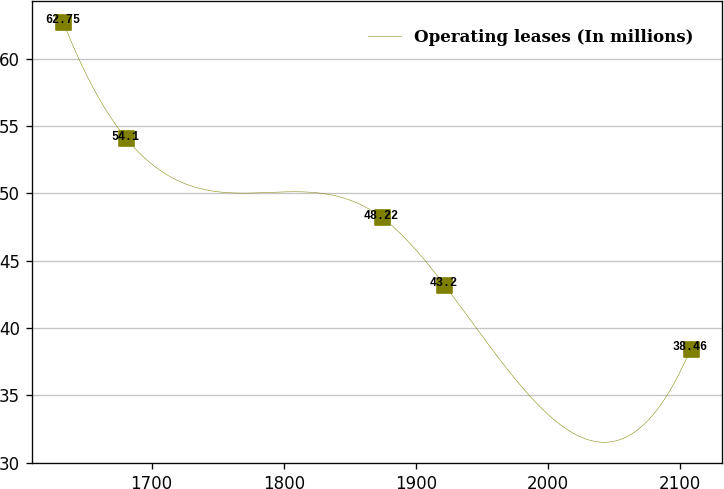Convert chart to OTSL. <chart><loc_0><loc_0><loc_500><loc_500><line_chart><ecel><fcel>Operating leases (In millions)<nl><fcel>1633.13<fcel>62.75<nl><fcel>1680.61<fcel>54.1<nl><fcel>1874.01<fcel>48.22<nl><fcel>1921.49<fcel>43.2<nl><fcel>2107.91<fcel>38.46<nl></chart> 